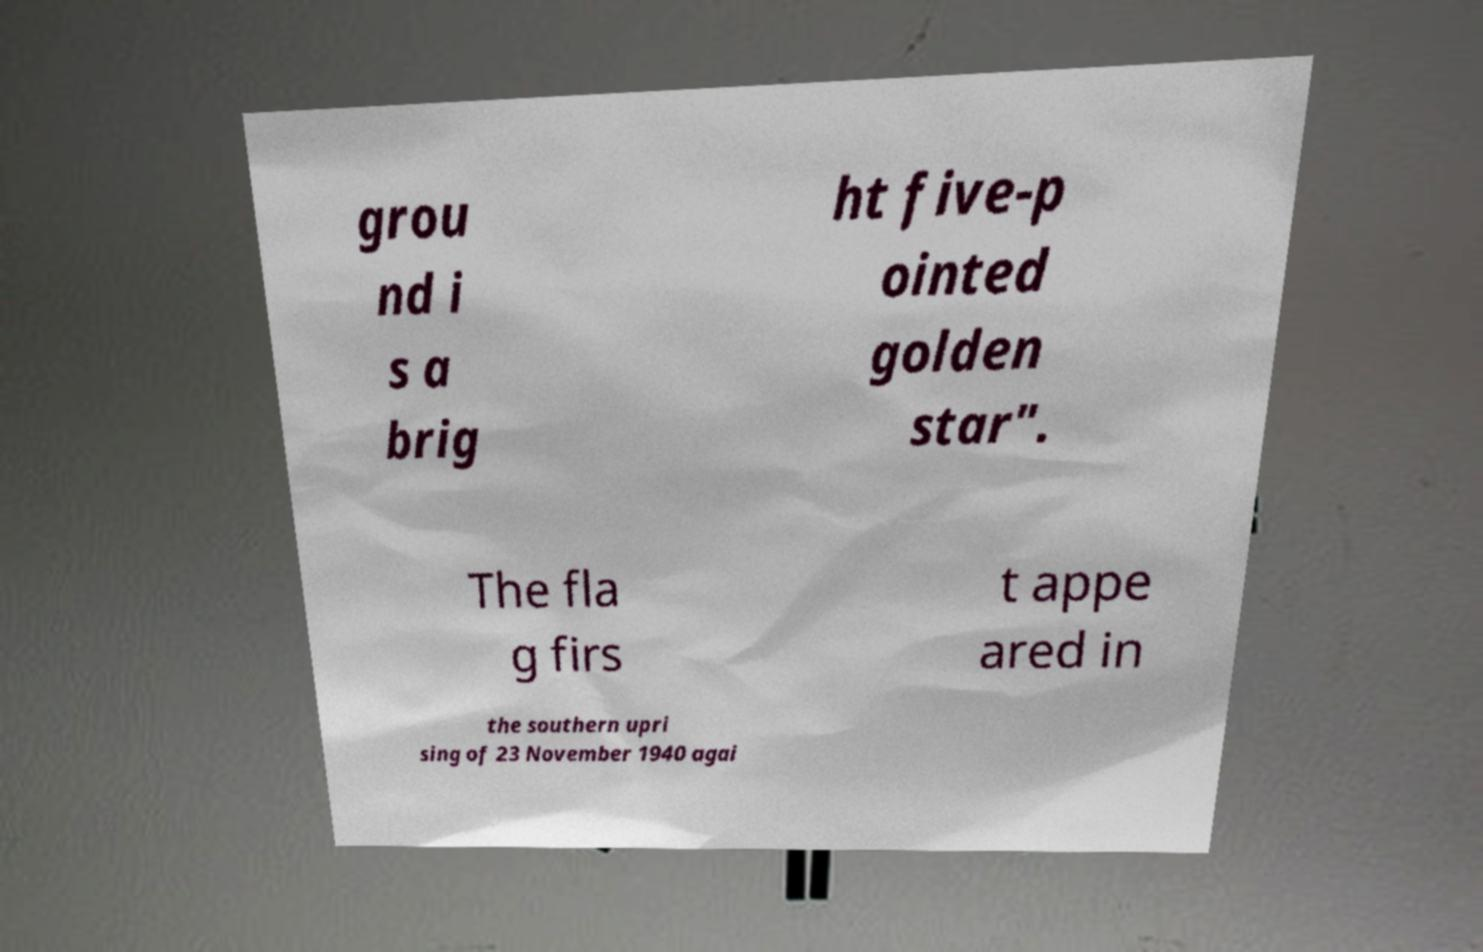Can you read and provide the text displayed in the image?This photo seems to have some interesting text. Can you extract and type it out for me? grou nd i s a brig ht five-p ointed golden star". The fla g firs t appe ared in the southern upri sing of 23 November 1940 agai 